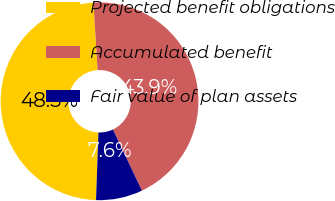Convert chart to OTSL. <chart><loc_0><loc_0><loc_500><loc_500><pie_chart><fcel>Projected benefit obligations<fcel>Accumulated benefit<fcel>Fair value of plan assets<nl><fcel>48.45%<fcel>43.94%<fcel>7.61%<nl></chart> 